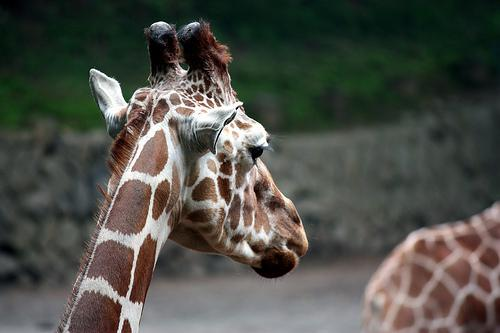Question: how many people?
Choices:
A. None.
B. Three.
C. Five.
D. Six.
Answer with the letter. Answer: A Question: what part of the animal is in front?
Choices:
A. Legs.
B. Head.
C. Tail.
D. Hooves.
Answer with the letter. Answer: B Question: how many giraffe?
Choices:
A. 7.
B. 3.
C. 2.
D. 5.
Answer with the letter. Answer: C Question: what is the animal?
Choices:
A. Zebra.
B. Lion.
C. Giraffe.
D. Wildebeest.
Answer with the letter. Answer: C 